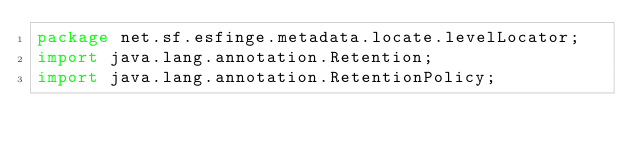Convert code to text. <code><loc_0><loc_0><loc_500><loc_500><_Java_>package net.sf.esfinge.metadata.locate.levelLocator;
import java.lang.annotation.Retention;
import java.lang.annotation.RetentionPolicy;
</code> 